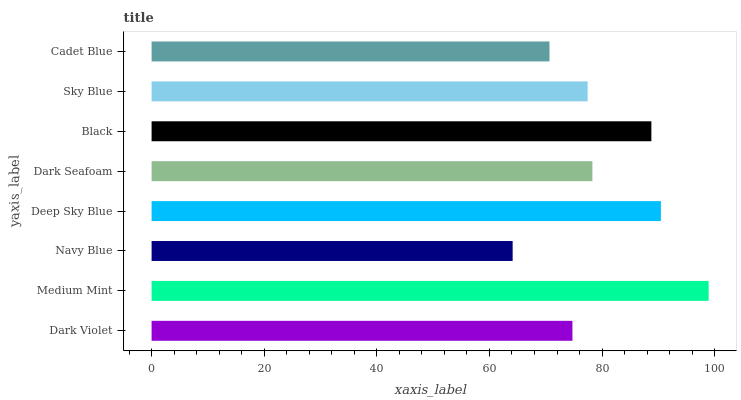Is Navy Blue the minimum?
Answer yes or no. Yes. Is Medium Mint the maximum?
Answer yes or no. Yes. Is Medium Mint the minimum?
Answer yes or no. No. Is Navy Blue the maximum?
Answer yes or no. No. Is Medium Mint greater than Navy Blue?
Answer yes or no. Yes. Is Navy Blue less than Medium Mint?
Answer yes or no. Yes. Is Navy Blue greater than Medium Mint?
Answer yes or no. No. Is Medium Mint less than Navy Blue?
Answer yes or no. No. Is Dark Seafoam the high median?
Answer yes or no. Yes. Is Sky Blue the low median?
Answer yes or no. Yes. Is Navy Blue the high median?
Answer yes or no. No. Is Dark Violet the low median?
Answer yes or no. No. 